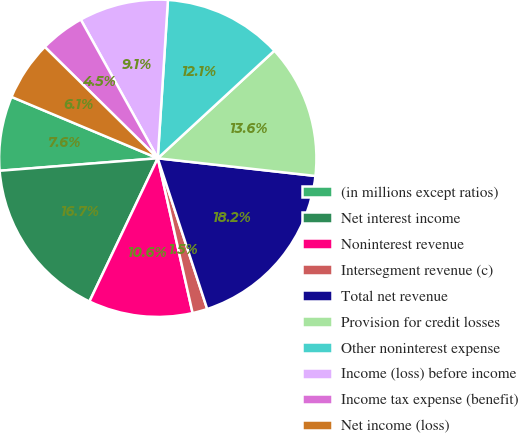<chart> <loc_0><loc_0><loc_500><loc_500><pie_chart><fcel>(in millions except ratios)<fcel>Net interest income<fcel>Noninterest revenue<fcel>Intersegment revenue (c)<fcel>Total net revenue<fcel>Provision for credit losses<fcel>Other noninterest expense<fcel>Income (loss) before income<fcel>Income tax expense (benefit)<fcel>Net income (loss)<nl><fcel>7.58%<fcel>16.66%<fcel>10.61%<fcel>1.52%<fcel>18.18%<fcel>13.64%<fcel>12.12%<fcel>9.09%<fcel>4.55%<fcel>6.06%<nl></chart> 